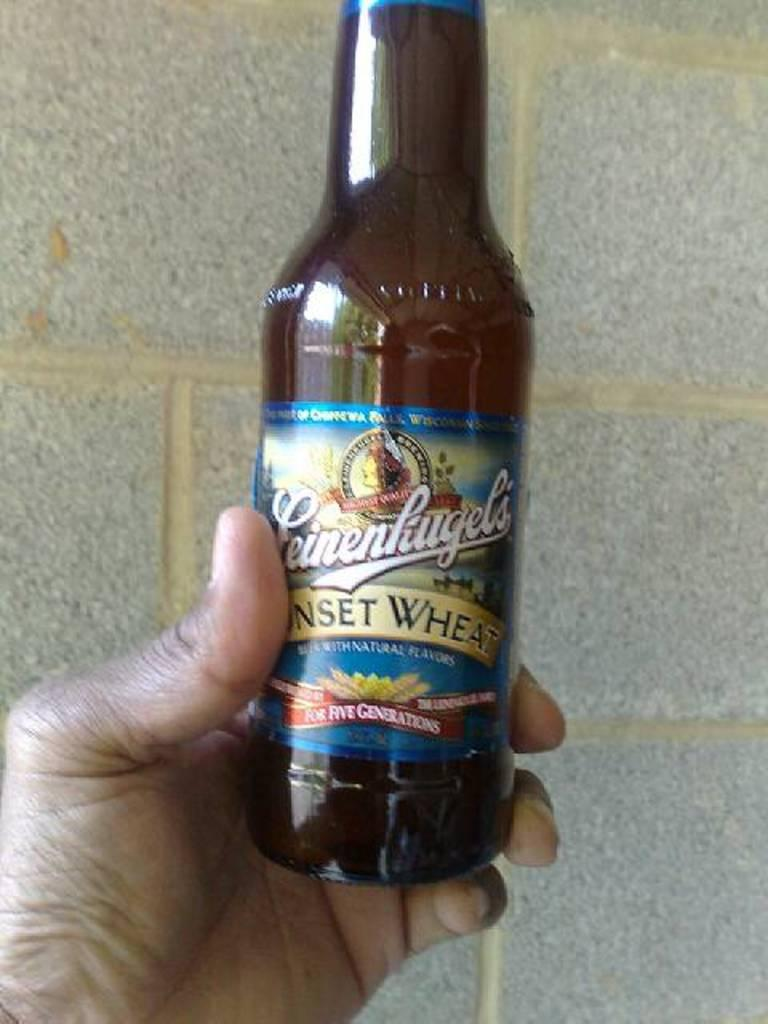<image>
Create a compact narrative representing the image presented. a close up of Feinenkugel's Sunset Wheat beer in a hand 